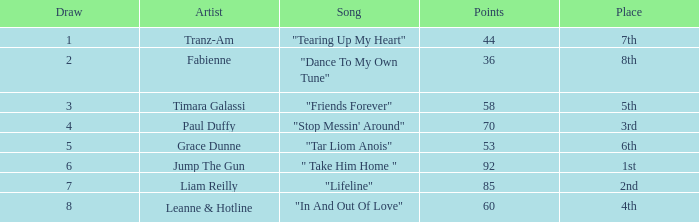What's the average amount of points for "in and out of love" with a draw over 8? None. Give me the full table as a dictionary. {'header': ['Draw', 'Artist', 'Song', 'Points', 'Place'], 'rows': [['1', 'Tranz-Am', '"Tearing Up My Heart"', '44', '7th'], ['2', 'Fabienne', '"Dance To My Own Tune"', '36', '8th'], ['3', 'Timara Galassi', '"Friends Forever"', '58', '5th'], ['4', 'Paul Duffy', '"Stop Messin\' Around"', '70', '3rd'], ['5', 'Grace Dunne', '"Tar Liom Anois"', '53', '6th'], ['6', 'Jump The Gun', '" Take Him Home "', '92', '1st'], ['7', 'Liam Reilly', '"Lifeline"', '85', '2nd'], ['8', 'Leanne & Hotline', '"In And Out Of Love"', '60', '4th']]} 